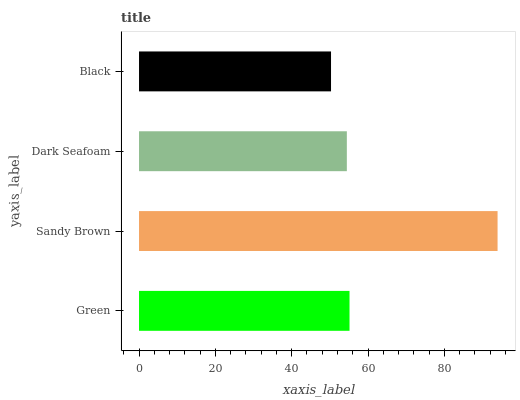Is Black the minimum?
Answer yes or no. Yes. Is Sandy Brown the maximum?
Answer yes or no. Yes. Is Dark Seafoam the minimum?
Answer yes or no. No. Is Dark Seafoam the maximum?
Answer yes or no. No. Is Sandy Brown greater than Dark Seafoam?
Answer yes or no. Yes. Is Dark Seafoam less than Sandy Brown?
Answer yes or no. Yes. Is Dark Seafoam greater than Sandy Brown?
Answer yes or no. No. Is Sandy Brown less than Dark Seafoam?
Answer yes or no. No. Is Green the high median?
Answer yes or no. Yes. Is Dark Seafoam the low median?
Answer yes or no. Yes. Is Black the high median?
Answer yes or no. No. Is Green the low median?
Answer yes or no. No. 